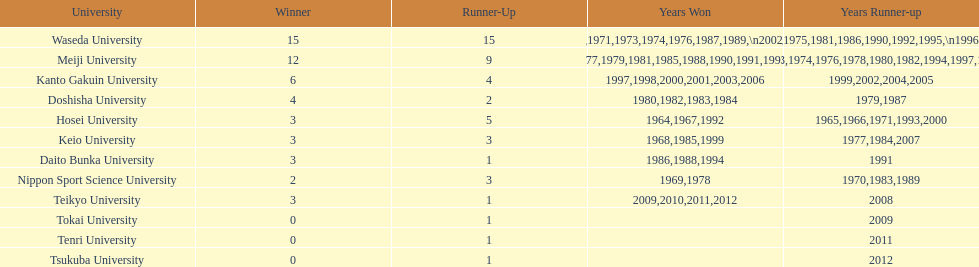Hosei won in 1964. who won the next year? Waseda University. 